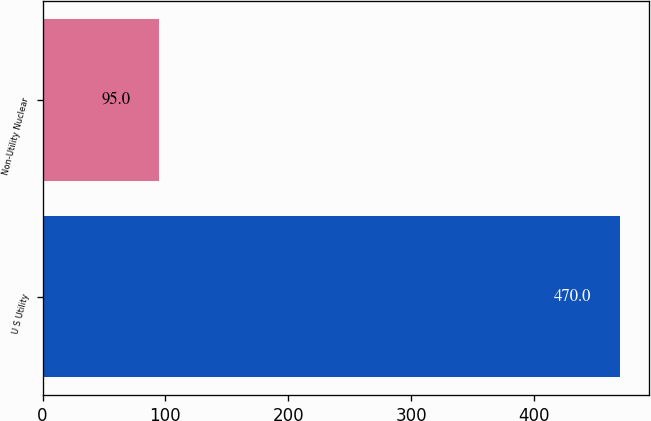Convert chart. <chart><loc_0><loc_0><loc_500><loc_500><bar_chart><fcel>U S Utility<fcel>Non-Utility Nuclear<nl><fcel>470<fcel>95<nl></chart> 